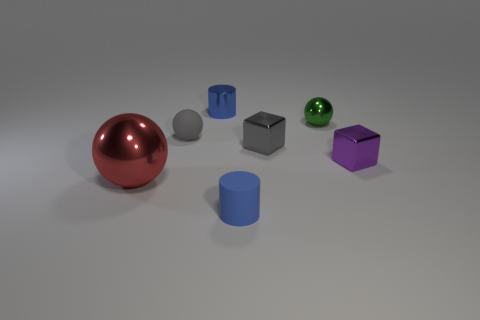There is a blue object in front of the large red shiny sphere; what is it made of?
Your answer should be compact. Rubber. Does the tiny gray object that is left of the tiny blue metal cylinder have the same material as the green object?
Give a very brief answer. No. Are any big blue metal balls visible?
Your answer should be compact. No. There is a small sphere that is made of the same material as the big red ball; what is its color?
Give a very brief answer. Green. What color is the small matte object in front of the small sphere that is left of the small matte object in front of the gray cube?
Your answer should be very brief. Blue. Does the gray shiny object have the same size as the matte object behind the large red ball?
Your answer should be compact. Yes. What number of things are either cylinders that are behind the red ball or tiny blue shiny objects that are left of the green ball?
Offer a terse response. 1. There is a gray shiny object that is the same size as the green ball; what shape is it?
Your answer should be very brief. Cube. There is a small blue object that is behind the small cylinder that is right of the tiny blue cylinder behind the gray matte ball; what shape is it?
Provide a short and direct response. Cylinder. Is the number of tiny rubber cylinders behind the purple thing the same as the number of big yellow spheres?
Your answer should be compact. Yes. 